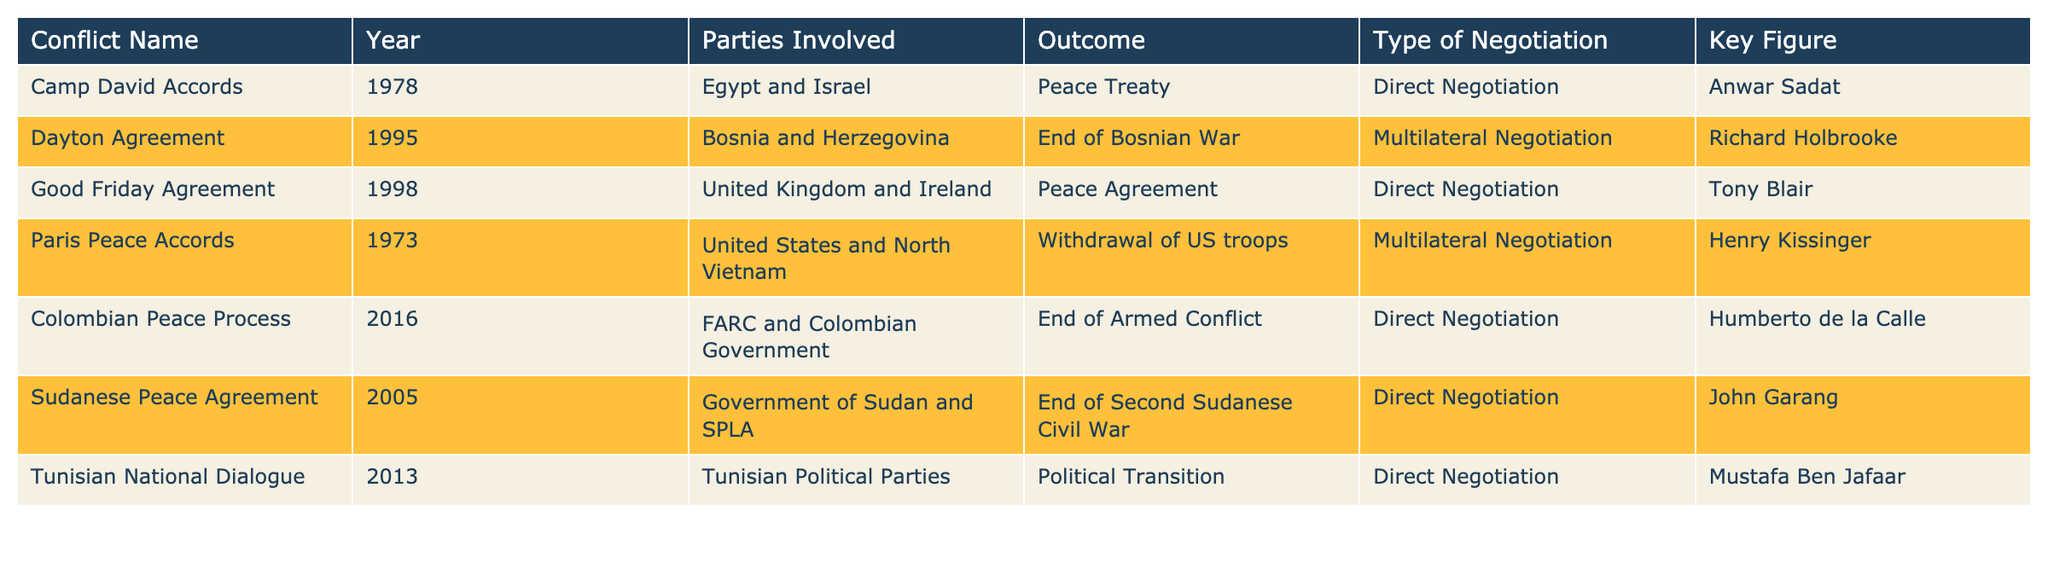What year was the Good Friday Agreement signed? The Good Friday Agreement is listed in the table with the year 1998.
Answer: 1998 Which conflict involved a peace treaty between Egypt and Israel? In the table, the conflict named the Camp David Accords is noted for involving a peace treaty between Egypt and Israel.
Answer: Camp David Accords How many conflicts were resolved through direct negotiation? By counting the rows with "Direct Negotiation" under the Type of Negotiation column, we see there are five conflicts: Camp David Accords, Good Friday Agreement, Colombian Peace Process, Sudanese Peace Agreement, and Tunisian National Dialogue.
Answer: 5 Did the Paris Peace Accords result in the withdrawal of troops? The table shows that the outcome of the Paris Peace Accords was the withdrawal of US troops, indicating that this fact is true.
Answer: Yes Which negotiation type had the most conflicts listed in the table? Looking at the table, "Direct Negotiation" appears in five entries, while "Multilateral Negotiation" appears twice. Therefore, direct negotiation had the most conflicts.
Answer: Direct Negotiation What is the outcome of the Dayton Agreement? The table indicates that the Dayton Agreement resulted in the end of the Bosnian War.
Answer: End of Bosnian War Which key figure was involved in the Sudanese Peace Agreement? The table shows that the key figure for the Sudanese Peace Agreement is John Garang.
Answer: John Garang If we consider only the conflicts that ended armed conflict, how many were resolved through direct negotiation? Filtering the table for conflicts that ended armed conflict, we find only one: the Colombian Peace Process, which was resolved through direct negotiation. This means the answer is one.
Answer: 1 Which two conflicts had multilateral negotiations and what were their outcomes? The Paris Peace Accords and the Dayton Agreement had multilateral negotiations. The Paris Peace Accords resulted in the withdrawal of US troops, while the Dayton Agreement resulted in the end of the Bosnian War.
Answer: Paris Peace Accords (withdrawal of US troops), Dayton Agreement (end of Bosnian War) 